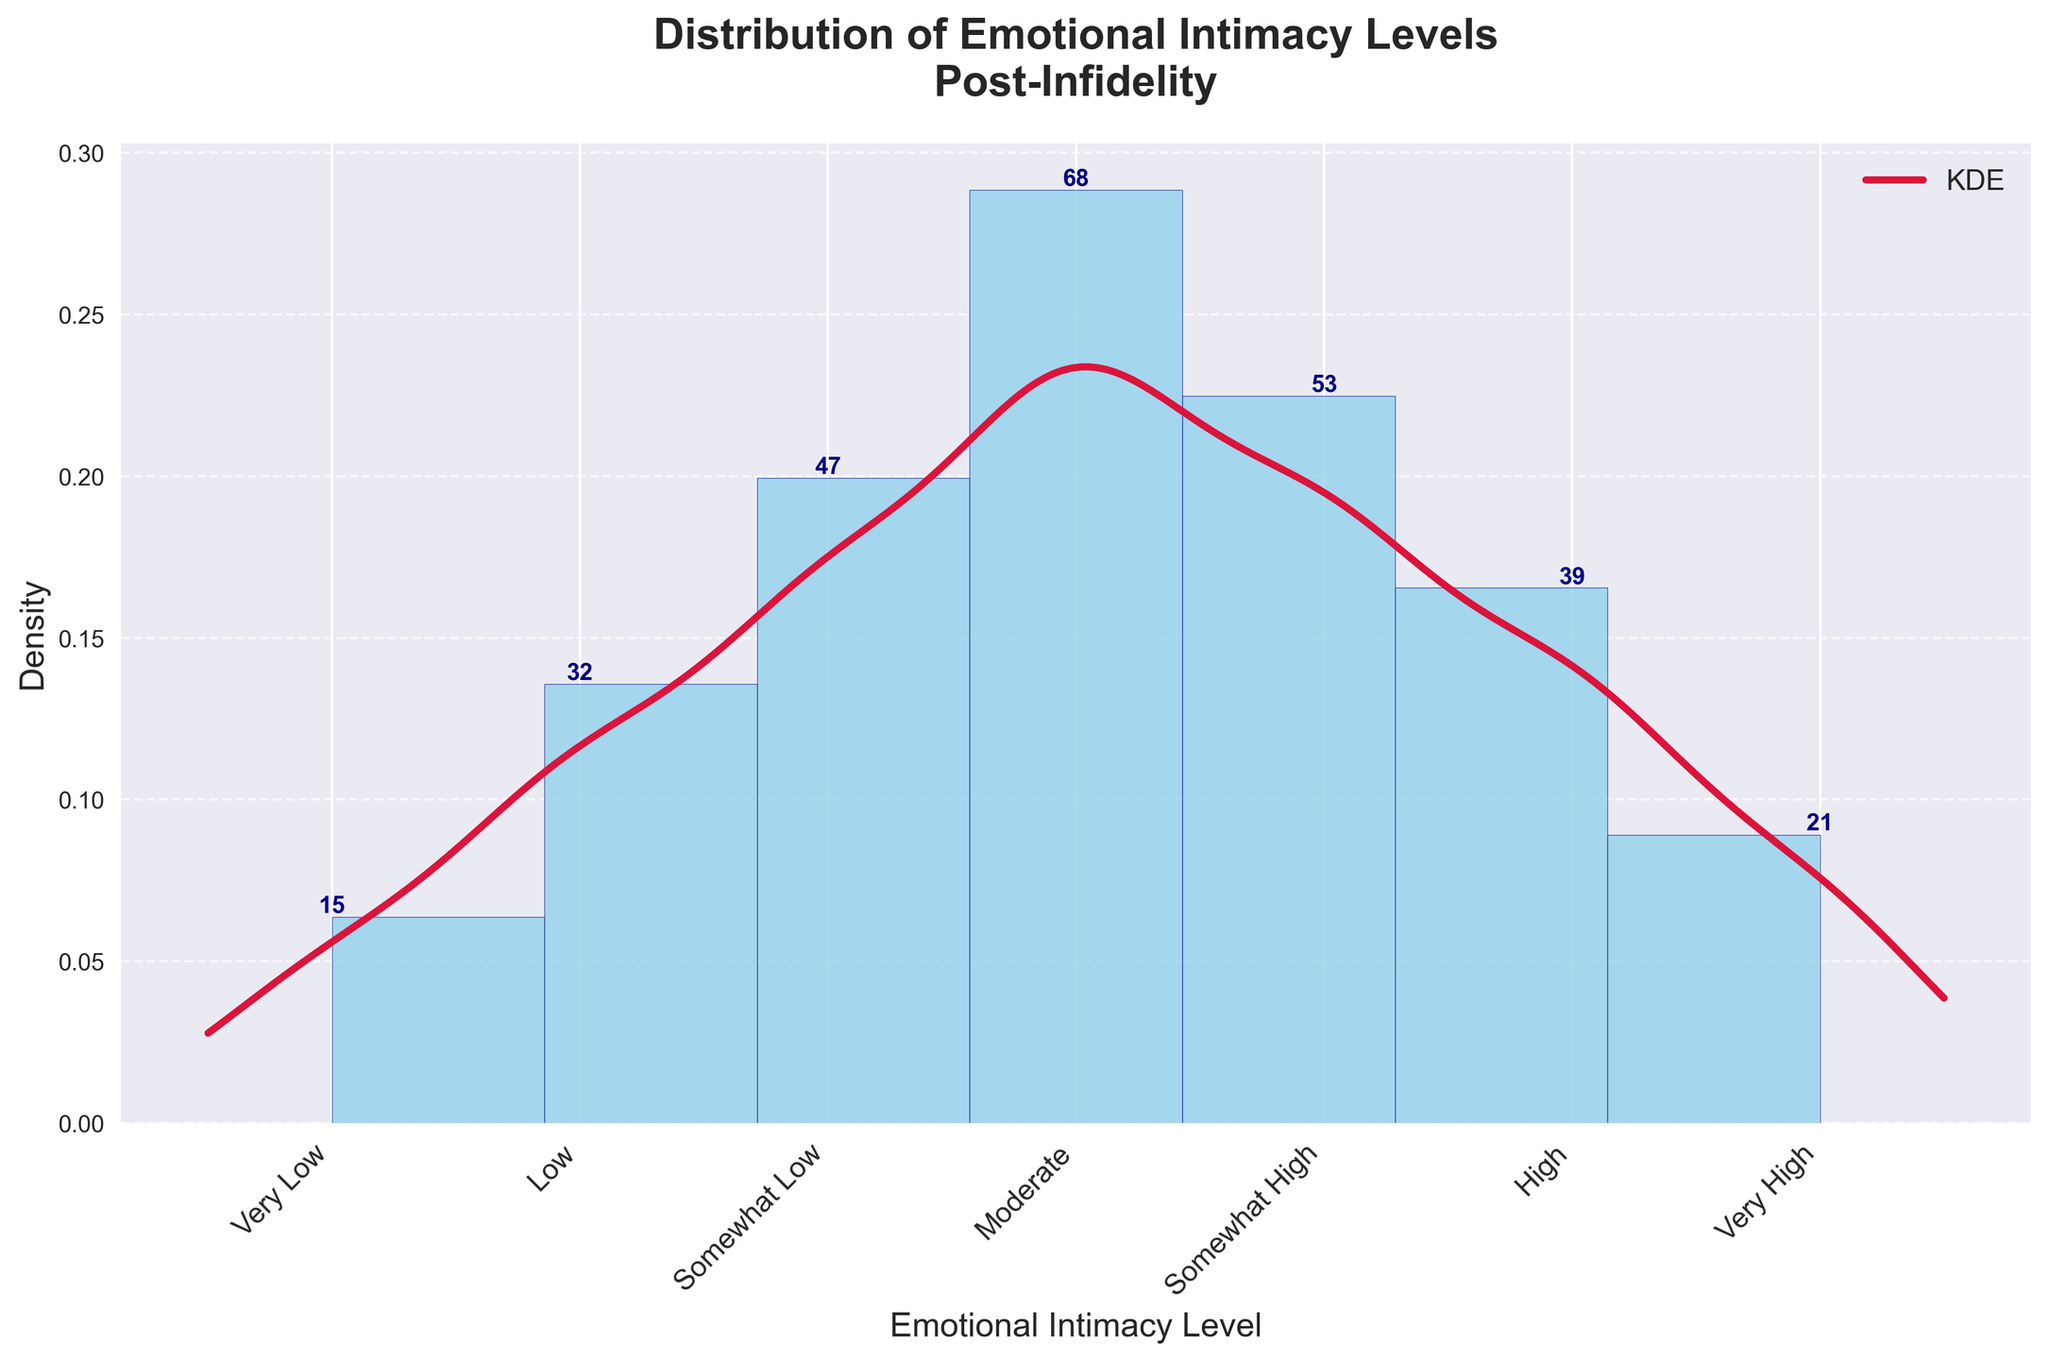What is the title of the plot? The title is usually located at the top of the figure and provides a brief description of the content. In this case, the title is "Distribution of Emotional Intimacy Levels\nPost-Infidelity".
Answer: Distribution of Emotional Intimacy Levels Post-Infidelity Which emotional intimacy level has the highest frequency? We need to identify the emotional intimacy level bar with the highest frequency label beside it. The "Moderate" level shows the highest frequency, with 68.
Answer: Moderate How many emotional intimacy levels are included in the data? To find the number of emotional intimacy levels, we can count the distinct bars along the x-axis. There are 7 levels shown.
Answer: 7 What is the frequency of the "Very High" emotional intimacy level? The frequency number is labeled beside each bar. For "Very High", it is 21.
Answer: 21 What is the sum of frequencies for "Very Low" and "High" emotional intimacy levels? The frequency for "Very Low" is 15 and for "High" is 39. Adding these values together gives 54.
Answer: 54 Which emotional intimacy level is less frequent, "Low" or "Very Low"? Compare the frequency labels on top of the bars. "Very Low" has a frequency of 15, and "Low" has a frequency of 32. "Very Low" is less frequent.
Answer: Very Low Is the overall distribution of emotional intimacy levels skewed or symmetric? By observing the histogram and KDE line, we can compare the spread of data. The distribution shows more data points on the left but the highest peaked in the middle, indicating a slight skew towards "Low" and "Moderate".
Answer: Skewed What are the emotional intimacy levels with above 50 frequencies? Check the frequency labels on each bar. The levels that have frequencies above 50 are "Moderate" (68) and "Somewhat High" (53).
Answer: Moderate, Somewhat High Which two consecutive emotional intimacy levels have the smallest difference in their frequencies? We need to find consecutive bars with the smallest numerical difference. "Somewhat High" (53) and "High" (39) have a difference of 14, which is smaller than the others.
Answer: Somewhat High and High 